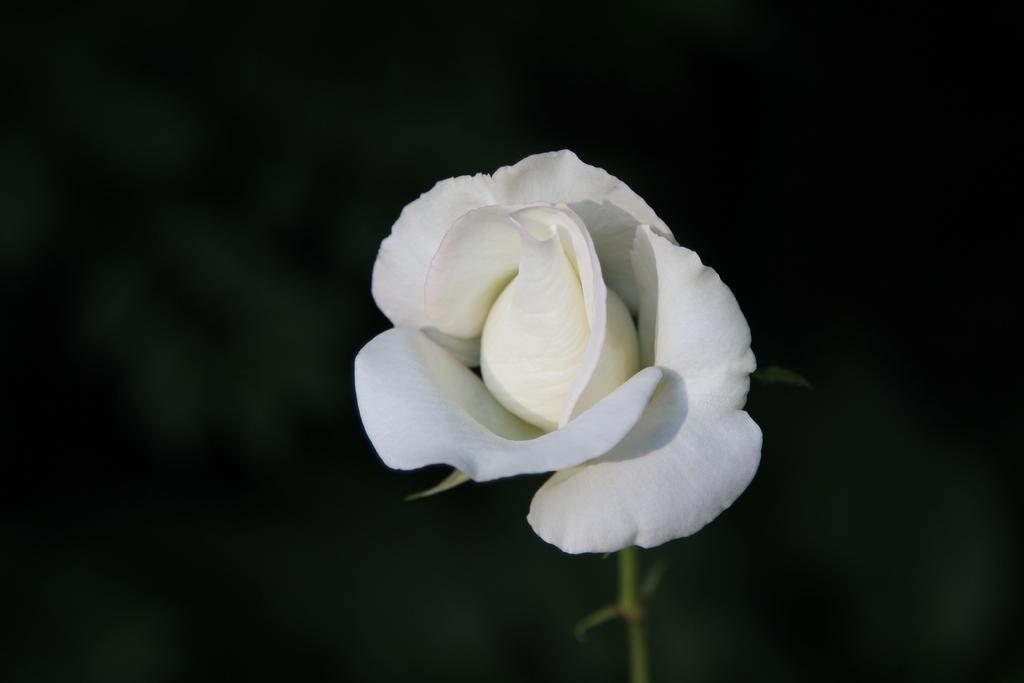How would you summarize this image in a sentence or two? In this image there is a white color flower, there is a stem truncated towards the bottom of the image, the background of the image is dark. 